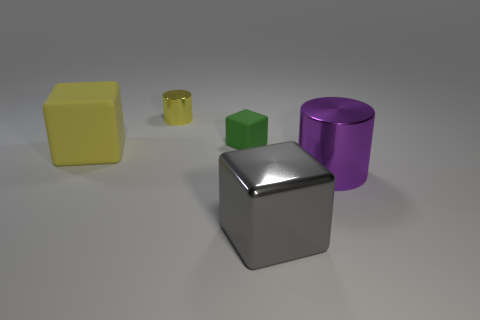Add 1 green shiny cylinders. How many objects exist? 6 Subtract all cylinders. How many objects are left? 3 Add 2 green matte blocks. How many green matte blocks are left? 3 Add 5 small yellow matte balls. How many small yellow matte balls exist? 5 Subtract 0 blue cubes. How many objects are left? 5 Subtract all big blocks. Subtract all tiny cylinders. How many objects are left? 2 